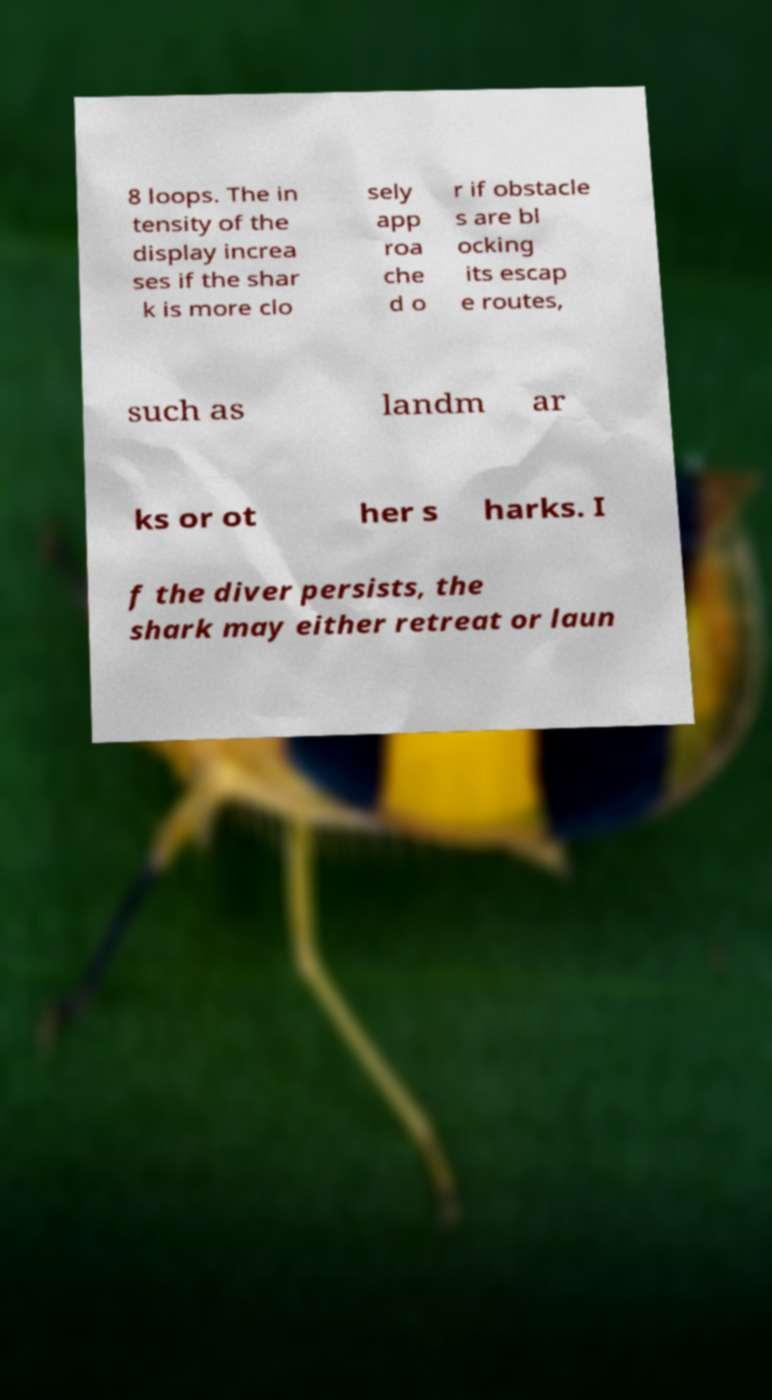Please read and relay the text visible in this image. What does it say? 8 loops. The in tensity of the display increa ses if the shar k is more clo sely app roa che d o r if obstacle s are bl ocking its escap e routes, such as landm ar ks or ot her s harks. I f the diver persists, the shark may either retreat or laun 